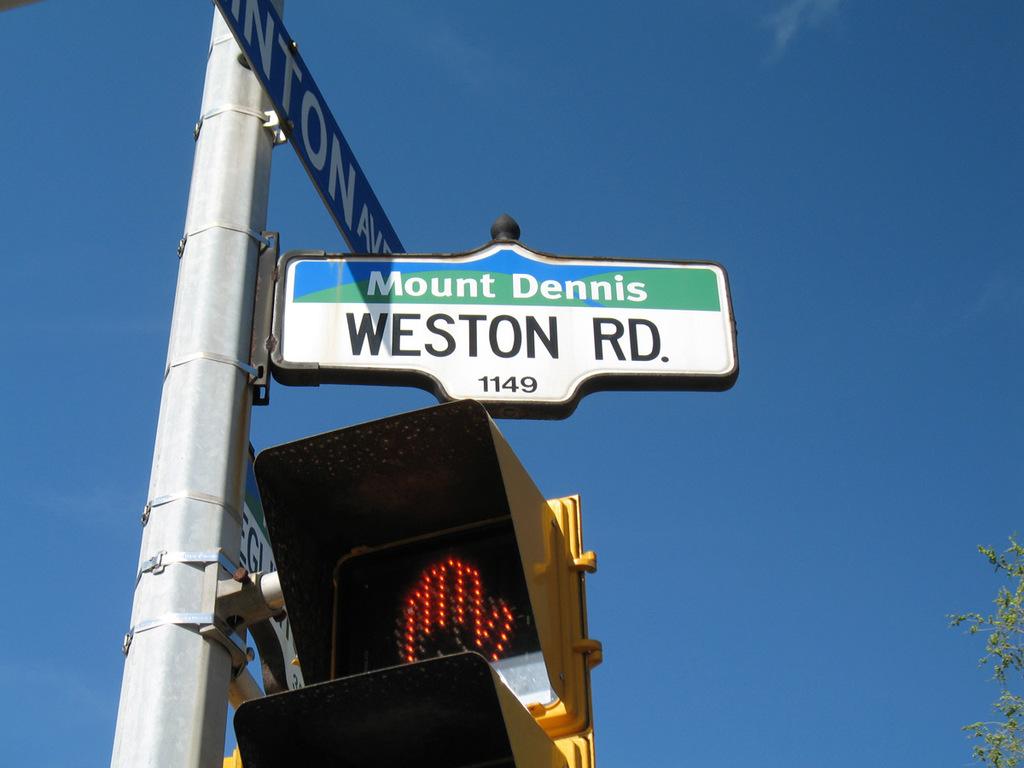What number is under the road name?
Your response must be concise. 1149. Where is mount dennis?
Make the answer very short. Weston rd. 